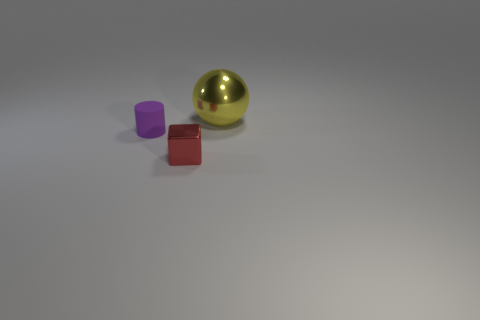There is a object that is both behind the tiny red metallic block and right of the purple cylinder; what is its shape?
Make the answer very short. Sphere. Is the size of the red shiny block the same as the yellow metallic ball?
Your answer should be compact. No. Are there any other gray spheres that have the same material as the sphere?
Offer a very short reply. No. How many tiny objects are both behind the tiny red thing and right of the rubber thing?
Offer a terse response. 0. There is a object that is on the right side of the red thing; what material is it?
Offer a terse response. Metal. What number of shiny cubes are the same color as the sphere?
Provide a succinct answer. 0. There is another object that is made of the same material as the red object; what is its size?
Offer a very short reply. Large. What number of objects are either tiny blue shiny cubes or shiny spheres?
Keep it short and to the point. 1. There is a shiny thing in front of the yellow sphere; what is its color?
Provide a succinct answer. Red. How many objects are either objects to the left of the yellow metallic ball or metal objects behind the tiny red cube?
Your answer should be compact. 3. 